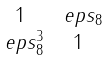<formula> <loc_0><loc_0><loc_500><loc_500>\begin{smallmatrix} 1 & \ e p s _ { 8 } \\ \ e p s _ { 8 } ^ { 3 } & 1 \end{smallmatrix}</formula> 